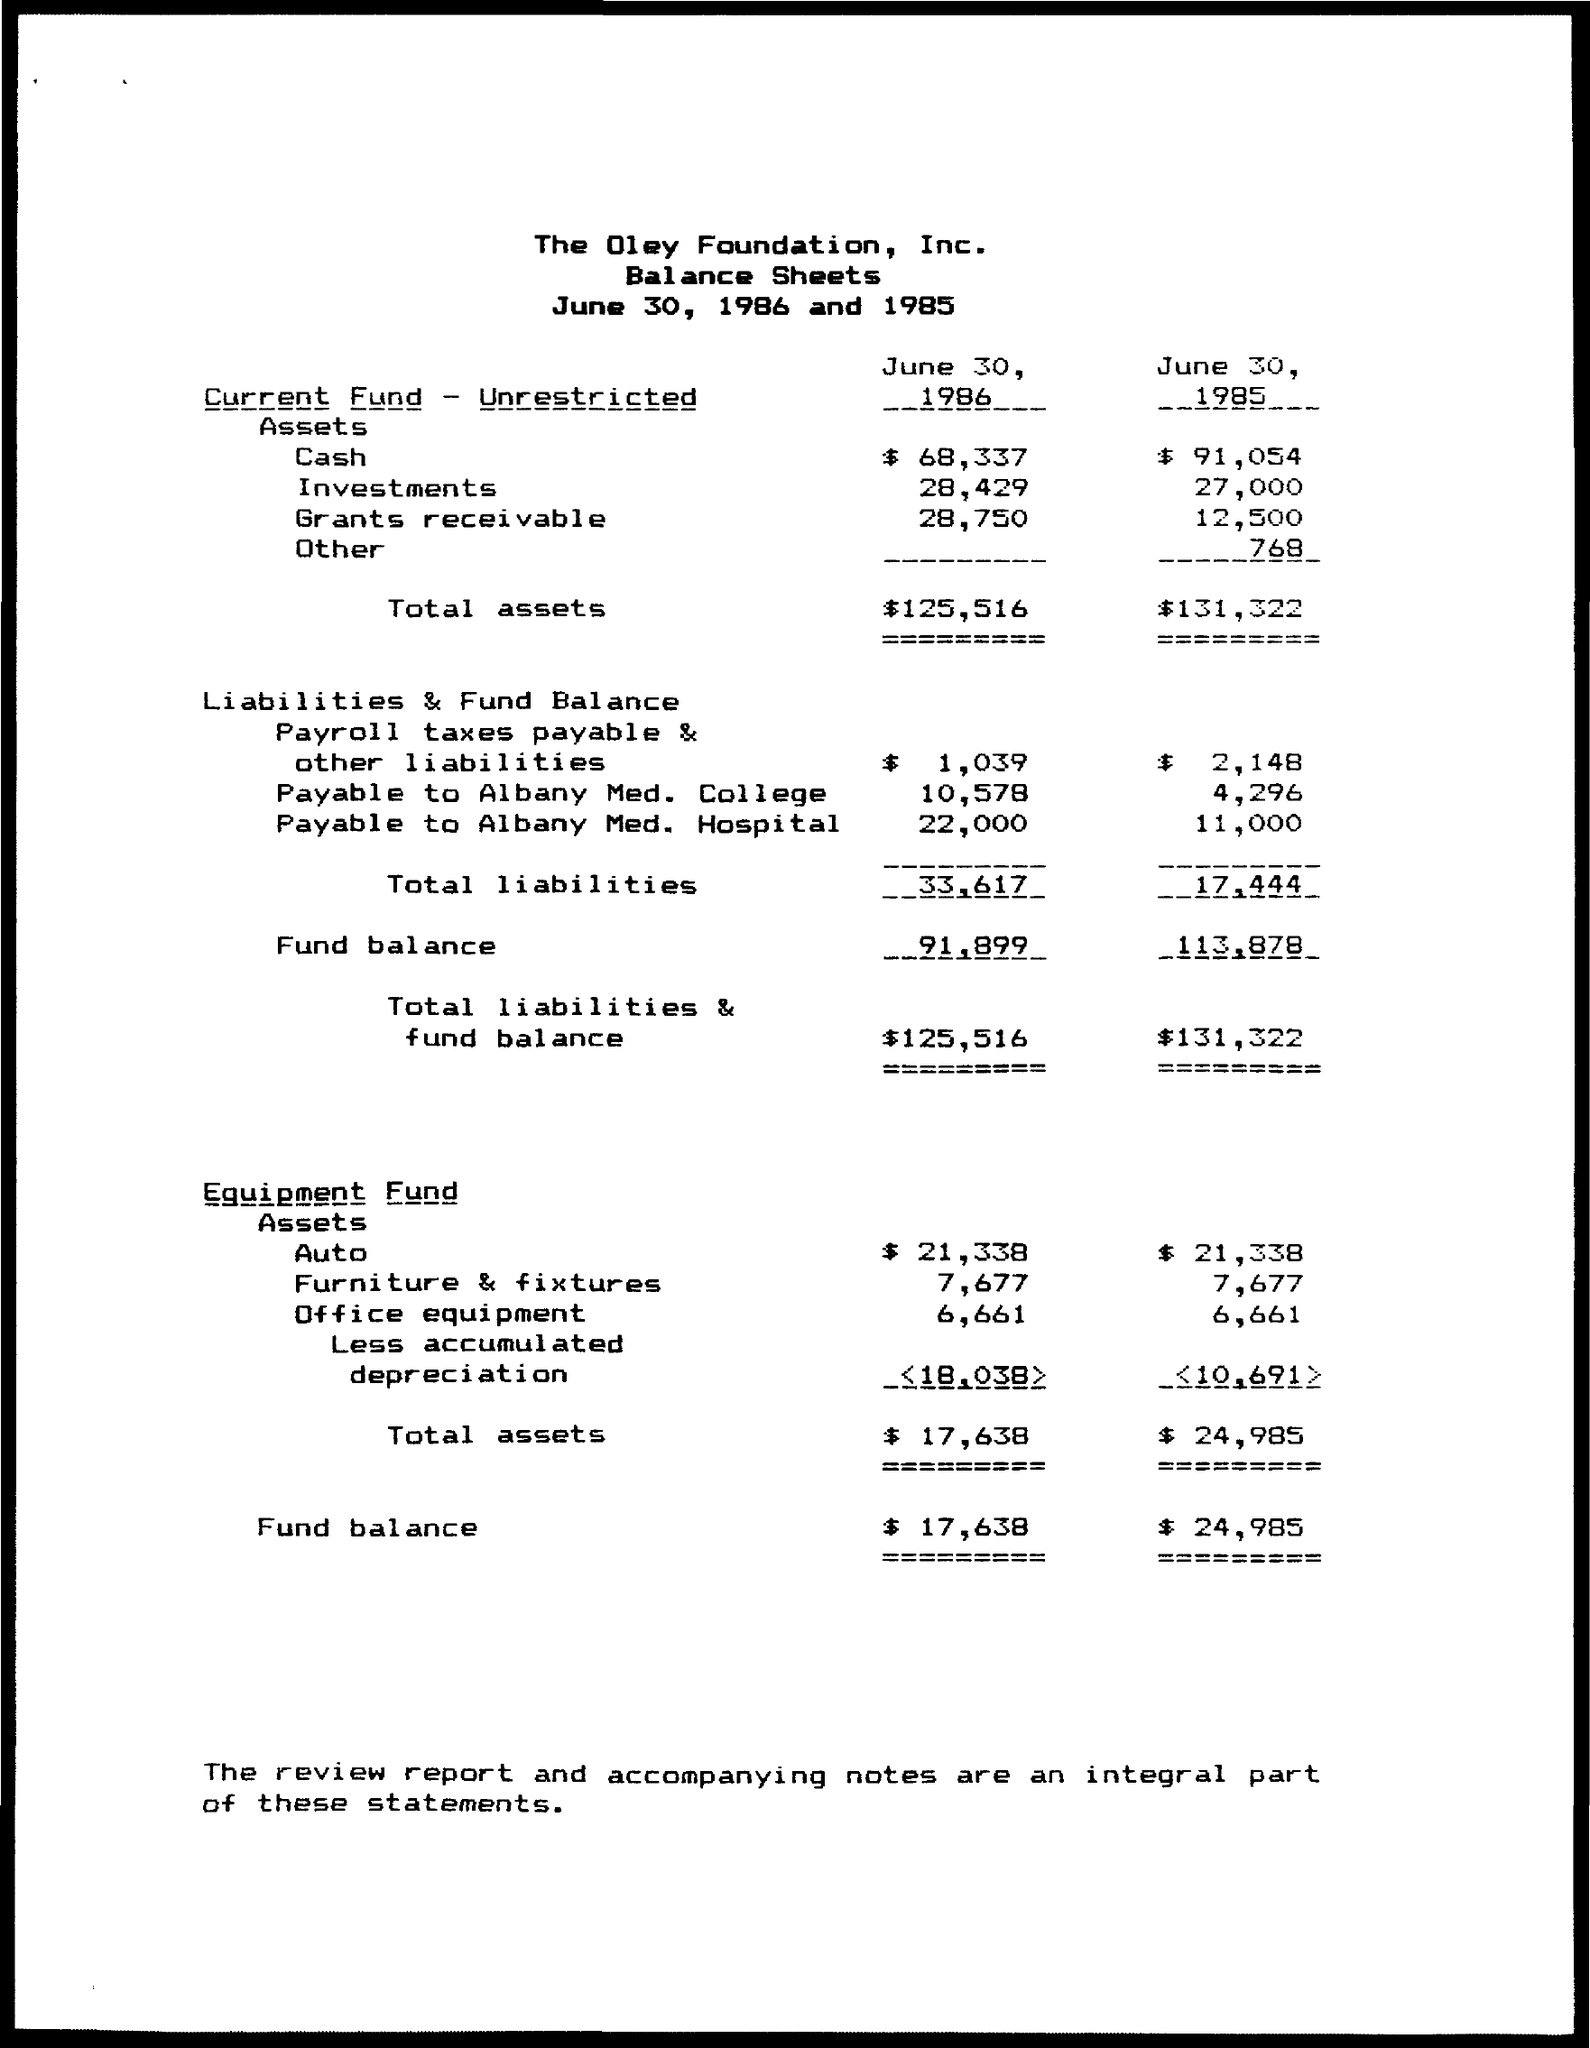Which company's balance sheet is given here?
Ensure brevity in your answer.  The Oley Foundation, Inc. What is the amount of  total assets on current fund - unrestricted  as on June 30, 1986?
Your answer should be compact. $125,516. What is the amount of total liabilities as on June 30, 1985?
Provide a short and direct response. 17,444. What is the amount of total liabilities & fund balance as on June 30, 1986?
Your response must be concise. 125,516. What is the amount of total assets on equipment fund as on June 30, 1986?
Provide a short and direct response. $ 17,638. What is an integral part of these statements?
Provide a short and direct response. The review report and accompanying notes. 